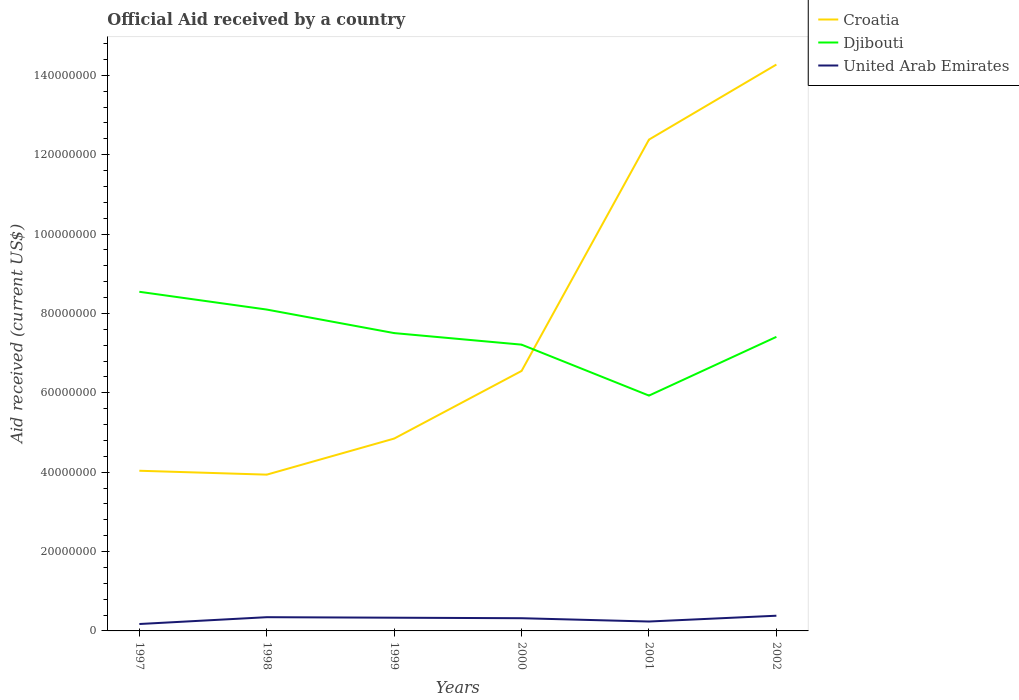How many different coloured lines are there?
Your answer should be very brief. 3. Does the line corresponding to Djibouti intersect with the line corresponding to United Arab Emirates?
Offer a very short reply. No. Across all years, what is the maximum net official aid received in Croatia?
Your answer should be compact. 3.94e+07. In which year was the net official aid received in Croatia maximum?
Offer a terse response. 1998. What is the total net official aid received in Croatia in the graph?
Offer a very short reply. -7.53e+07. What is the difference between the highest and the second highest net official aid received in United Arab Emirates?
Make the answer very short. 2.09e+06. Is the net official aid received in United Arab Emirates strictly greater than the net official aid received in Djibouti over the years?
Give a very brief answer. Yes. What is the difference between two consecutive major ticks on the Y-axis?
Your answer should be very brief. 2.00e+07. Does the graph contain any zero values?
Ensure brevity in your answer.  No. Does the graph contain grids?
Your answer should be compact. No. How are the legend labels stacked?
Your response must be concise. Vertical. What is the title of the graph?
Offer a very short reply. Official Aid received by a country. What is the label or title of the X-axis?
Ensure brevity in your answer.  Years. What is the label or title of the Y-axis?
Ensure brevity in your answer.  Aid received (current US$). What is the Aid received (current US$) of Croatia in 1997?
Your answer should be compact. 4.04e+07. What is the Aid received (current US$) in Djibouti in 1997?
Keep it short and to the point. 8.55e+07. What is the Aid received (current US$) of United Arab Emirates in 1997?
Offer a very short reply. 1.74e+06. What is the Aid received (current US$) of Croatia in 1998?
Make the answer very short. 3.94e+07. What is the Aid received (current US$) of Djibouti in 1998?
Ensure brevity in your answer.  8.10e+07. What is the Aid received (current US$) of United Arab Emirates in 1998?
Ensure brevity in your answer.  3.46e+06. What is the Aid received (current US$) in Croatia in 1999?
Provide a short and direct response. 4.85e+07. What is the Aid received (current US$) of Djibouti in 1999?
Your answer should be very brief. 7.50e+07. What is the Aid received (current US$) in United Arab Emirates in 1999?
Make the answer very short. 3.33e+06. What is the Aid received (current US$) of Croatia in 2000?
Your answer should be compact. 6.55e+07. What is the Aid received (current US$) of Djibouti in 2000?
Give a very brief answer. 7.21e+07. What is the Aid received (current US$) of United Arab Emirates in 2000?
Your answer should be compact. 3.20e+06. What is the Aid received (current US$) of Croatia in 2001?
Your answer should be very brief. 1.24e+08. What is the Aid received (current US$) of Djibouti in 2001?
Give a very brief answer. 5.93e+07. What is the Aid received (current US$) of United Arab Emirates in 2001?
Ensure brevity in your answer.  2.37e+06. What is the Aid received (current US$) of Croatia in 2002?
Make the answer very short. 1.43e+08. What is the Aid received (current US$) in Djibouti in 2002?
Your answer should be very brief. 7.41e+07. What is the Aid received (current US$) in United Arab Emirates in 2002?
Provide a short and direct response. 3.83e+06. Across all years, what is the maximum Aid received (current US$) in Croatia?
Offer a terse response. 1.43e+08. Across all years, what is the maximum Aid received (current US$) in Djibouti?
Give a very brief answer. 8.55e+07. Across all years, what is the maximum Aid received (current US$) of United Arab Emirates?
Your response must be concise. 3.83e+06. Across all years, what is the minimum Aid received (current US$) of Croatia?
Keep it short and to the point. 3.94e+07. Across all years, what is the minimum Aid received (current US$) in Djibouti?
Make the answer very short. 5.93e+07. Across all years, what is the minimum Aid received (current US$) in United Arab Emirates?
Your answer should be very brief. 1.74e+06. What is the total Aid received (current US$) of Croatia in the graph?
Give a very brief answer. 4.60e+08. What is the total Aid received (current US$) of Djibouti in the graph?
Offer a very short reply. 4.47e+08. What is the total Aid received (current US$) of United Arab Emirates in the graph?
Ensure brevity in your answer.  1.79e+07. What is the difference between the Aid received (current US$) in Croatia in 1997 and that in 1998?
Offer a very short reply. 9.80e+05. What is the difference between the Aid received (current US$) of Djibouti in 1997 and that in 1998?
Your answer should be compact. 4.48e+06. What is the difference between the Aid received (current US$) of United Arab Emirates in 1997 and that in 1998?
Give a very brief answer. -1.72e+06. What is the difference between the Aid received (current US$) of Croatia in 1997 and that in 1999?
Your response must be concise. -8.11e+06. What is the difference between the Aid received (current US$) of Djibouti in 1997 and that in 1999?
Your answer should be compact. 1.04e+07. What is the difference between the Aid received (current US$) in United Arab Emirates in 1997 and that in 1999?
Provide a short and direct response. -1.59e+06. What is the difference between the Aid received (current US$) of Croatia in 1997 and that in 2000?
Keep it short and to the point. -2.52e+07. What is the difference between the Aid received (current US$) of Djibouti in 1997 and that in 2000?
Ensure brevity in your answer.  1.33e+07. What is the difference between the Aid received (current US$) in United Arab Emirates in 1997 and that in 2000?
Your response must be concise. -1.46e+06. What is the difference between the Aid received (current US$) of Croatia in 1997 and that in 2001?
Your answer should be compact. -8.34e+07. What is the difference between the Aid received (current US$) in Djibouti in 1997 and that in 2001?
Your answer should be compact. 2.62e+07. What is the difference between the Aid received (current US$) in United Arab Emirates in 1997 and that in 2001?
Provide a short and direct response. -6.30e+05. What is the difference between the Aid received (current US$) in Croatia in 1997 and that in 2002?
Make the answer very short. -1.02e+08. What is the difference between the Aid received (current US$) in Djibouti in 1997 and that in 2002?
Your answer should be very brief. 1.14e+07. What is the difference between the Aid received (current US$) in United Arab Emirates in 1997 and that in 2002?
Your answer should be very brief. -2.09e+06. What is the difference between the Aid received (current US$) in Croatia in 1998 and that in 1999?
Offer a very short reply. -9.09e+06. What is the difference between the Aid received (current US$) of Djibouti in 1998 and that in 1999?
Make the answer very short. 5.93e+06. What is the difference between the Aid received (current US$) in United Arab Emirates in 1998 and that in 1999?
Give a very brief answer. 1.30e+05. What is the difference between the Aid received (current US$) in Croatia in 1998 and that in 2000?
Give a very brief answer. -2.61e+07. What is the difference between the Aid received (current US$) in Djibouti in 1998 and that in 2000?
Make the answer very short. 8.84e+06. What is the difference between the Aid received (current US$) in United Arab Emirates in 1998 and that in 2000?
Your answer should be very brief. 2.60e+05. What is the difference between the Aid received (current US$) in Croatia in 1998 and that in 2001?
Ensure brevity in your answer.  -8.44e+07. What is the difference between the Aid received (current US$) in Djibouti in 1998 and that in 2001?
Ensure brevity in your answer.  2.17e+07. What is the difference between the Aid received (current US$) in United Arab Emirates in 1998 and that in 2001?
Make the answer very short. 1.09e+06. What is the difference between the Aid received (current US$) of Croatia in 1998 and that in 2002?
Your answer should be compact. -1.03e+08. What is the difference between the Aid received (current US$) in Djibouti in 1998 and that in 2002?
Provide a succinct answer. 6.88e+06. What is the difference between the Aid received (current US$) of United Arab Emirates in 1998 and that in 2002?
Provide a short and direct response. -3.70e+05. What is the difference between the Aid received (current US$) in Croatia in 1999 and that in 2000?
Your answer should be compact. -1.70e+07. What is the difference between the Aid received (current US$) in Djibouti in 1999 and that in 2000?
Give a very brief answer. 2.91e+06. What is the difference between the Aid received (current US$) in Croatia in 1999 and that in 2001?
Keep it short and to the point. -7.53e+07. What is the difference between the Aid received (current US$) of Djibouti in 1999 and that in 2001?
Offer a terse response. 1.58e+07. What is the difference between the Aid received (current US$) in United Arab Emirates in 1999 and that in 2001?
Your response must be concise. 9.60e+05. What is the difference between the Aid received (current US$) of Croatia in 1999 and that in 2002?
Ensure brevity in your answer.  -9.42e+07. What is the difference between the Aid received (current US$) of Djibouti in 1999 and that in 2002?
Give a very brief answer. 9.50e+05. What is the difference between the Aid received (current US$) of United Arab Emirates in 1999 and that in 2002?
Ensure brevity in your answer.  -5.00e+05. What is the difference between the Aid received (current US$) in Croatia in 2000 and that in 2001?
Keep it short and to the point. -5.83e+07. What is the difference between the Aid received (current US$) in Djibouti in 2000 and that in 2001?
Give a very brief answer. 1.28e+07. What is the difference between the Aid received (current US$) in United Arab Emirates in 2000 and that in 2001?
Make the answer very short. 8.30e+05. What is the difference between the Aid received (current US$) in Croatia in 2000 and that in 2002?
Ensure brevity in your answer.  -7.72e+07. What is the difference between the Aid received (current US$) in Djibouti in 2000 and that in 2002?
Make the answer very short. -1.96e+06. What is the difference between the Aid received (current US$) in United Arab Emirates in 2000 and that in 2002?
Give a very brief answer. -6.30e+05. What is the difference between the Aid received (current US$) in Croatia in 2001 and that in 2002?
Offer a very short reply. -1.89e+07. What is the difference between the Aid received (current US$) of Djibouti in 2001 and that in 2002?
Offer a terse response. -1.48e+07. What is the difference between the Aid received (current US$) of United Arab Emirates in 2001 and that in 2002?
Give a very brief answer. -1.46e+06. What is the difference between the Aid received (current US$) in Croatia in 1997 and the Aid received (current US$) in Djibouti in 1998?
Offer a terse response. -4.06e+07. What is the difference between the Aid received (current US$) in Croatia in 1997 and the Aid received (current US$) in United Arab Emirates in 1998?
Your answer should be very brief. 3.69e+07. What is the difference between the Aid received (current US$) of Djibouti in 1997 and the Aid received (current US$) of United Arab Emirates in 1998?
Your response must be concise. 8.20e+07. What is the difference between the Aid received (current US$) in Croatia in 1997 and the Aid received (current US$) in Djibouti in 1999?
Your answer should be very brief. -3.47e+07. What is the difference between the Aid received (current US$) of Croatia in 1997 and the Aid received (current US$) of United Arab Emirates in 1999?
Offer a very short reply. 3.70e+07. What is the difference between the Aid received (current US$) in Djibouti in 1997 and the Aid received (current US$) in United Arab Emirates in 1999?
Make the answer very short. 8.21e+07. What is the difference between the Aid received (current US$) in Croatia in 1997 and the Aid received (current US$) in Djibouti in 2000?
Give a very brief answer. -3.18e+07. What is the difference between the Aid received (current US$) in Croatia in 1997 and the Aid received (current US$) in United Arab Emirates in 2000?
Provide a succinct answer. 3.72e+07. What is the difference between the Aid received (current US$) in Djibouti in 1997 and the Aid received (current US$) in United Arab Emirates in 2000?
Provide a succinct answer. 8.23e+07. What is the difference between the Aid received (current US$) in Croatia in 1997 and the Aid received (current US$) in Djibouti in 2001?
Provide a succinct answer. -1.89e+07. What is the difference between the Aid received (current US$) of Croatia in 1997 and the Aid received (current US$) of United Arab Emirates in 2001?
Make the answer very short. 3.80e+07. What is the difference between the Aid received (current US$) of Djibouti in 1997 and the Aid received (current US$) of United Arab Emirates in 2001?
Your answer should be compact. 8.31e+07. What is the difference between the Aid received (current US$) in Croatia in 1997 and the Aid received (current US$) in Djibouti in 2002?
Offer a terse response. -3.37e+07. What is the difference between the Aid received (current US$) in Croatia in 1997 and the Aid received (current US$) in United Arab Emirates in 2002?
Ensure brevity in your answer.  3.65e+07. What is the difference between the Aid received (current US$) in Djibouti in 1997 and the Aid received (current US$) in United Arab Emirates in 2002?
Offer a terse response. 8.16e+07. What is the difference between the Aid received (current US$) of Croatia in 1998 and the Aid received (current US$) of Djibouti in 1999?
Keep it short and to the point. -3.57e+07. What is the difference between the Aid received (current US$) of Croatia in 1998 and the Aid received (current US$) of United Arab Emirates in 1999?
Offer a terse response. 3.60e+07. What is the difference between the Aid received (current US$) of Djibouti in 1998 and the Aid received (current US$) of United Arab Emirates in 1999?
Offer a very short reply. 7.76e+07. What is the difference between the Aid received (current US$) of Croatia in 1998 and the Aid received (current US$) of Djibouti in 2000?
Give a very brief answer. -3.28e+07. What is the difference between the Aid received (current US$) in Croatia in 1998 and the Aid received (current US$) in United Arab Emirates in 2000?
Give a very brief answer. 3.62e+07. What is the difference between the Aid received (current US$) in Djibouti in 1998 and the Aid received (current US$) in United Arab Emirates in 2000?
Keep it short and to the point. 7.78e+07. What is the difference between the Aid received (current US$) in Croatia in 1998 and the Aid received (current US$) in Djibouti in 2001?
Give a very brief answer. -1.99e+07. What is the difference between the Aid received (current US$) of Croatia in 1998 and the Aid received (current US$) of United Arab Emirates in 2001?
Your response must be concise. 3.70e+07. What is the difference between the Aid received (current US$) of Djibouti in 1998 and the Aid received (current US$) of United Arab Emirates in 2001?
Offer a very short reply. 7.86e+07. What is the difference between the Aid received (current US$) in Croatia in 1998 and the Aid received (current US$) in Djibouti in 2002?
Offer a very short reply. -3.47e+07. What is the difference between the Aid received (current US$) of Croatia in 1998 and the Aid received (current US$) of United Arab Emirates in 2002?
Ensure brevity in your answer.  3.56e+07. What is the difference between the Aid received (current US$) in Djibouti in 1998 and the Aid received (current US$) in United Arab Emirates in 2002?
Provide a succinct answer. 7.72e+07. What is the difference between the Aid received (current US$) of Croatia in 1999 and the Aid received (current US$) of Djibouti in 2000?
Offer a very short reply. -2.37e+07. What is the difference between the Aid received (current US$) of Croatia in 1999 and the Aid received (current US$) of United Arab Emirates in 2000?
Give a very brief answer. 4.53e+07. What is the difference between the Aid received (current US$) of Djibouti in 1999 and the Aid received (current US$) of United Arab Emirates in 2000?
Your answer should be compact. 7.18e+07. What is the difference between the Aid received (current US$) in Croatia in 1999 and the Aid received (current US$) in Djibouti in 2001?
Ensure brevity in your answer.  -1.08e+07. What is the difference between the Aid received (current US$) of Croatia in 1999 and the Aid received (current US$) of United Arab Emirates in 2001?
Make the answer very short. 4.61e+07. What is the difference between the Aid received (current US$) of Djibouti in 1999 and the Aid received (current US$) of United Arab Emirates in 2001?
Provide a succinct answer. 7.27e+07. What is the difference between the Aid received (current US$) in Croatia in 1999 and the Aid received (current US$) in Djibouti in 2002?
Give a very brief answer. -2.56e+07. What is the difference between the Aid received (current US$) in Croatia in 1999 and the Aid received (current US$) in United Arab Emirates in 2002?
Offer a very short reply. 4.46e+07. What is the difference between the Aid received (current US$) of Djibouti in 1999 and the Aid received (current US$) of United Arab Emirates in 2002?
Your answer should be very brief. 7.12e+07. What is the difference between the Aid received (current US$) in Croatia in 2000 and the Aid received (current US$) in Djibouti in 2001?
Provide a succinct answer. 6.21e+06. What is the difference between the Aid received (current US$) in Croatia in 2000 and the Aid received (current US$) in United Arab Emirates in 2001?
Offer a terse response. 6.31e+07. What is the difference between the Aid received (current US$) in Djibouti in 2000 and the Aid received (current US$) in United Arab Emirates in 2001?
Offer a very short reply. 6.98e+07. What is the difference between the Aid received (current US$) of Croatia in 2000 and the Aid received (current US$) of Djibouti in 2002?
Provide a succinct answer. -8.59e+06. What is the difference between the Aid received (current US$) of Croatia in 2000 and the Aid received (current US$) of United Arab Emirates in 2002?
Provide a succinct answer. 6.17e+07. What is the difference between the Aid received (current US$) in Djibouti in 2000 and the Aid received (current US$) in United Arab Emirates in 2002?
Offer a very short reply. 6.83e+07. What is the difference between the Aid received (current US$) of Croatia in 2001 and the Aid received (current US$) of Djibouti in 2002?
Provide a short and direct response. 4.97e+07. What is the difference between the Aid received (current US$) of Croatia in 2001 and the Aid received (current US$) of United Arab Emirates in 2002?
Make the answer very short. 1.20e+08. What is the difference between the Aid received (current US$) of Djibouti in 2001 and the Aid received (current US$) of United Arab Emirates in 2002?
Your answer should be compact. 5.55e+07. What is the average Aid received (current US$) of Croatia per year?
Keep it short and to the point. 7.67e+07. What is the average Aid received (current US$) of Djibouti per year?
Ensure brevity in your answer.  7.45e+07. What is the average Aid received (current US$) in United Arab Emirates per year?
Provide a short and direct response. 2.99e+06. In the year 1997, what is the difference between the Aid received (current US$) of Croatia and Aid received (current US$) of Djibouti?
Your answer should be very brief. -4.51e+07. In the year 1997, what is the difference between the Aid received (current US$) of Croatia and Aid received (current US$) of United Arab Emirates?
Your answer should be very brief. 3.86e+07. In the year 1997, what is the difference between the Aid received (current US$) of Djibouti and Aid received (current US$) of United Arab Emirates?
Make the answer very short. 8.37e+07. In the year 1998, what is the difference between the Aid received (current US$) of Croatia and Aid received (current US$) of Djibouti?
Your answer should be very brief. -4.16e+07. In the year 1998, what is the difference between the Aid received (current US$) of Croatia and Aid received (current US$) of United Arab Emirates?
Your response must be concise. 3.59e+07. In the year 1998, what is the difference between the Aid received (current US$) of Djibouti and Aid received (current US$) of United Arab Emirates?
Give a very brief answer. 7.75e+07. In the year 1999, what is the difference between the Aid received (current US$) of Croatia and Aid received (current US$) of Djibouti?
Provide a succinct answer. -2.66e+07. In the year 1999, what is the difference between the Aid received (current US$) of Croatia and Aid received (current US$) of United Arab Emirates?
Offer a terse response. 4.51e+07. In the year 1999, what is the difference between the Aid received (current US$) of Djibouti and Aid received (current US$) of United Arab Emirates?
Provide a succinct answer. 7.17e+07. In the year 2000, what is the difference between the Aid received (current US$) in Croatia and Aid received (current US$) in Djibouti?
Provide a succinct answer. -6.63e+06. In the year 2000, what is the difference between the Aid received (current US$) of Croatia and Aid received (current US$) of United Arab Emirates?
Provide a short and direct response. 6.23e+07. In the year 2000, what is the difference between the Aid received (current US$) of Djibouti and Aid received (current US$) of United Arab Emirates?
Offer a terse response. 6.89e+07. In the year 2001, what is the difference between the Aid received (current US$) of Croatia and Aid received (current US$) of Djibouti?
Your response must be concise. 6.45e+07. In the year 2001, what is the difference between the Aid received (current US$) in Croatia and Aid received (current US$) in United Arab Emirates?
Your answer should be very brief. 1.21e+08. In the year 2001, what is the difference between the Aid received (current US$) of Djibouti and Aid received (current US$) of United Arab Emirates?
Provide a succinct answer. 5.69e+07. In the year 2002, what is the difference between the Aid received (current US$) in Croatia and Aid received (current US$) in Djibouti?
Keep it short and to the point. 6.86e+07. In the year 2002, what is the difference between the Aid received (current US$) of Croatia and Aid received (current US$) of United Arab Emirates?
Your answer should be compact. 1.39e+08. In the year 2002, what is the difference between the Aid received (current US$) in Djibouti and Aid received (current US$) in United Arab Emirates?
Offer a very short reply. 7.03e+07. What is the ratio of the Aid received (current US$) in Croatia in 1997 to that in 1998?
Keep it short and to the point. 1.02. What is the ratio of the Aid received (current US$) in Djibouti in 1997 to that in 1998?
Provide a succinct answer. 1.06. What is the ratio of the Aid received (current US$) in United Arab Emirates in 1997 to that in 1998?
Offer a very short reply. 0.5. What is the ratio of the Aid received (current US$) of Croatia in 1997 to that in 1999?
Give a very brief answer. 0.83. What is the ratio of the Aid received (current US$) in Djibouti in 1997 to that in 1999?
Your answer should be very brief. 1.14. What is the ratio of the Aid received (current US$) of United Arab Emirates in 1997 to that in 1999?
Your answer should be very brief. 0.52. What is the ratio of the Aid received (current US$) in Croatia in 1997 to that in 2000?
Make the answer very short. 0.62. What is the ratio of the Aid received (current US$) in Djibouti in 1997 to that in 2000?
Your answer should be very brief. 1.18. What is the ratio of the Aid received (current US$) of United Arab Emirates in 1997 to that in 2000?
Provide a short and direct response. 0.54. What is the ratio of the Aid received (current US$) in Croatia in 1997 to that in 2001?
Your response must be concise. 0.33. What is the ratio of the Aid received (current US$) in Djibouti in 1997 to that in 2001?
Your response must be concise. 1.44. What is the ratio of the Aid received (current US$) of United Arab Emirates in 1997 to that in 2001?
Provide a succinct answer. 0.73. What is the ratio of the Aid received (current US$) of Croatia in 1997 to that in 2002?
Offer a very short reply. 0.28. What is the ratio of the Aid received (current US$) of Djibouti in 1997 to that in 2002?
Provide a succinct answer. 1.15. What is the ratio of the Aid received (current US$) of United Arab Emirates in 1997 to that in 2002?
Provide a succinct answer. 0.45. What is the ratio of the Aid received (current US$) of Croatia in 1998 to that in 1999?
Ensure brevity in your answer.  0.81. What is the ratio of the Aid received (current US$) of Djibouti in 1998 to that in 1999?
Provide a succinct answer. 1.08. What is the ratio of the Aid received (current US$) in United Arab Emirates in 1998 to that in 1999?
Offer a very short reply. 1.04. What is the ratio of the Aid received (current US$) of Croatia in 1998 to that in 2000?
Keep it short and to the point. 0.6. What is the ratio of the Aid received (current US$) of Djibouti in 1998 to that in 2000?
Offer a terse response. 1.12. What is the ratio of the Aid received (current US$) of United Arab Emirates in 1998 to that in 2000?
Keep it short and to the point. 1.08. What is the ratio of the Aid received (current US$) of Croatia in 1998 to that in 2001?
Offer a terse response. 0.32. What is the ratio of the Aid received (current US$) in Djibouti in 1998 to that in 2001?
Keep it short and to the point. 1.37. What is the ratio of the Aid received (current US$) of United Arab Emirates in 1998 to that in 2001?
Provide a succinct answer. 1.46. What is the ratio of the Aid received (current US$) of Croatia in 1998 to that in 2002?
Offer a terse response. 0.28. What is the ratio of the Aid received (current US$) of Djibouti in 1998 to that in 2002?
Your answer should be compact. 1.09. What is the ratio of the Aid received (current US$) of United Arab Emirates in 1998 to that in 2002?
Keep it short and to the point. 0.9. What is the ratio of the Aid received (current US$) of Croatia in 1999 to that in 2000?
Keep it short and to the point. 0.74. What is the ratio of the Aid received (current US$) of Djibouti in 1999 to that in 2000?
Ensure brevity in your answer.  1.04. What is the ratio of the Aid received (current US$) in United Arab Emirates in 1999 to that in 2000?
Ensure brevity in your answer.  1.04. What is the ratio of the Aid received (current US$) of Croatia in 1999 to that in 2001?
Give a very brief answer. 0.39. What is the ratio of the Aid received (current US$) of Djibouti in 1999 to that in 2001?
Your response must be concise. 1.27. What is the ratio of the Aid received (current US$) of United Arab Emirates in 1999 to that in 2001?
Provide a succinct answer. 1.41. What is the ratio of the Aid received (current US$) of Croatia in 1999 to that in 2002?
Keep it short and to the point. 0.34. What is the ratio of the Aid received (current US$) of Djibouti in 1999 to that in 2002?
Your answer should be very brief. 1.01. What is the ratio of the Aid received (current US$) in United Arab Emirates in 1999 to that in 2002?
Your answer should be compact. 0.87. What is the ratio of the Aid received (current US$) in Croatia in 2000 to that in 2001?
Offer a very short reply. 0.53. What is the ratio of the Aid received (current US$) in Djibouti in 2000 to that in 2001?
Your answer should be very brief. 1.22. What is the ratio of the Aid received (current US$) of United Arab Emirates in 2000 to that in 2001?
Your answer should be very brief. 1.35. What is the ratio of the Aid received (current US$) in Croatia in 2000 to that in 2002?
Make the answer very short. 0.46. What is the ratio of the Aid received (current US$) in Djibouti in 2000 to that in 2002?
Provide a short and direct response. 0.97. What is the ratio of the Aid received (current US$) in United Arab Emirates in 2000 to that in 2002?
Offer a terse response. 0.84. What is the ratio of the Aid received (current US$) in Croatia in 2001 to that in 2002?
Your response must be concise. 0.87. What is the ratio of the Aid received (current US$) in Djibouti in 2001 to that in 2002?
Your answer should be very brief. 0.8. What is the ratio of the Aid received (current US$) of United Arab Emirates in 2001 to that in 2002?
Ensure brevity in your answer.  0.62. What is the difference between the highest and the second highest Aid received (current US$) in Croatia?
Your answer should be very brief. 1.89e+07. What is the difference between the highest and the second highest Aid received (current US$) in Djibouti?
Your answer should be very brief. 4.48e+06. What is the difference between the highest and the second highest Aid received (current US$) of United Arab Emirates?
Your answer should be compact. 3.70e+05. What is the difference between the highest and the lowest Aid received (current US$) of Croatia?
Your answer should be compact. 1.03e+08. What is the difference between the highest and the lowest Aid received (current US$) in Djibouti?
Ensure brevity in your answer.  2.62e+07. What is the difference between the highest and the lowest Aid received (current US$) in United Arab Emirates?
Provide a succinct answer. 2.09e+06. 